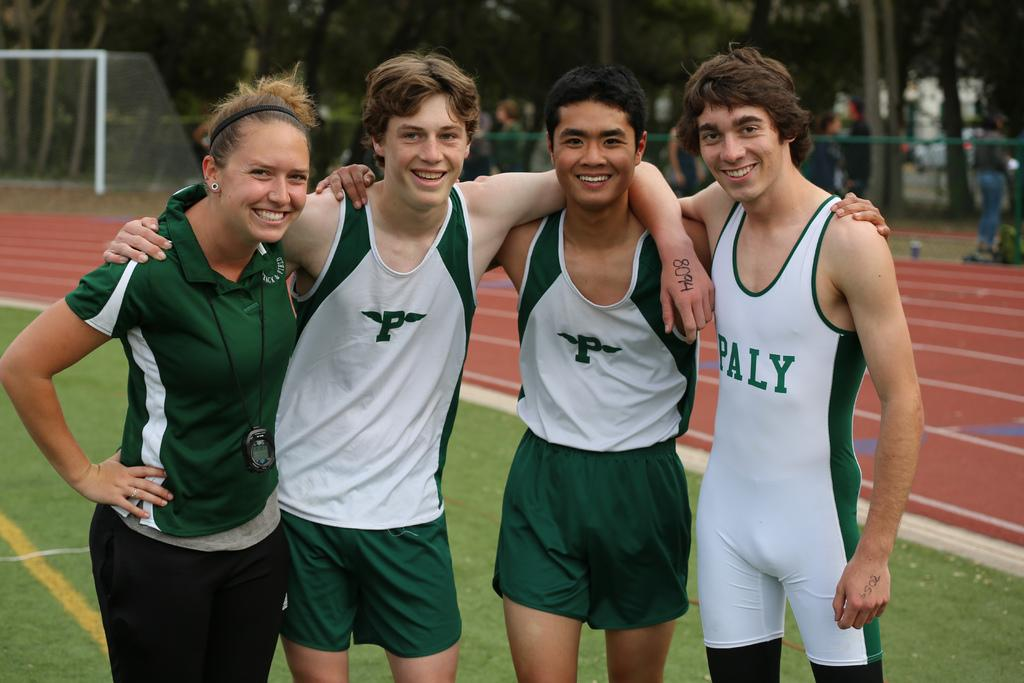<image>
Create a compact narrative representing the image presented. A sports team stands on a field, one of them with the PALY logo on their leotard. 